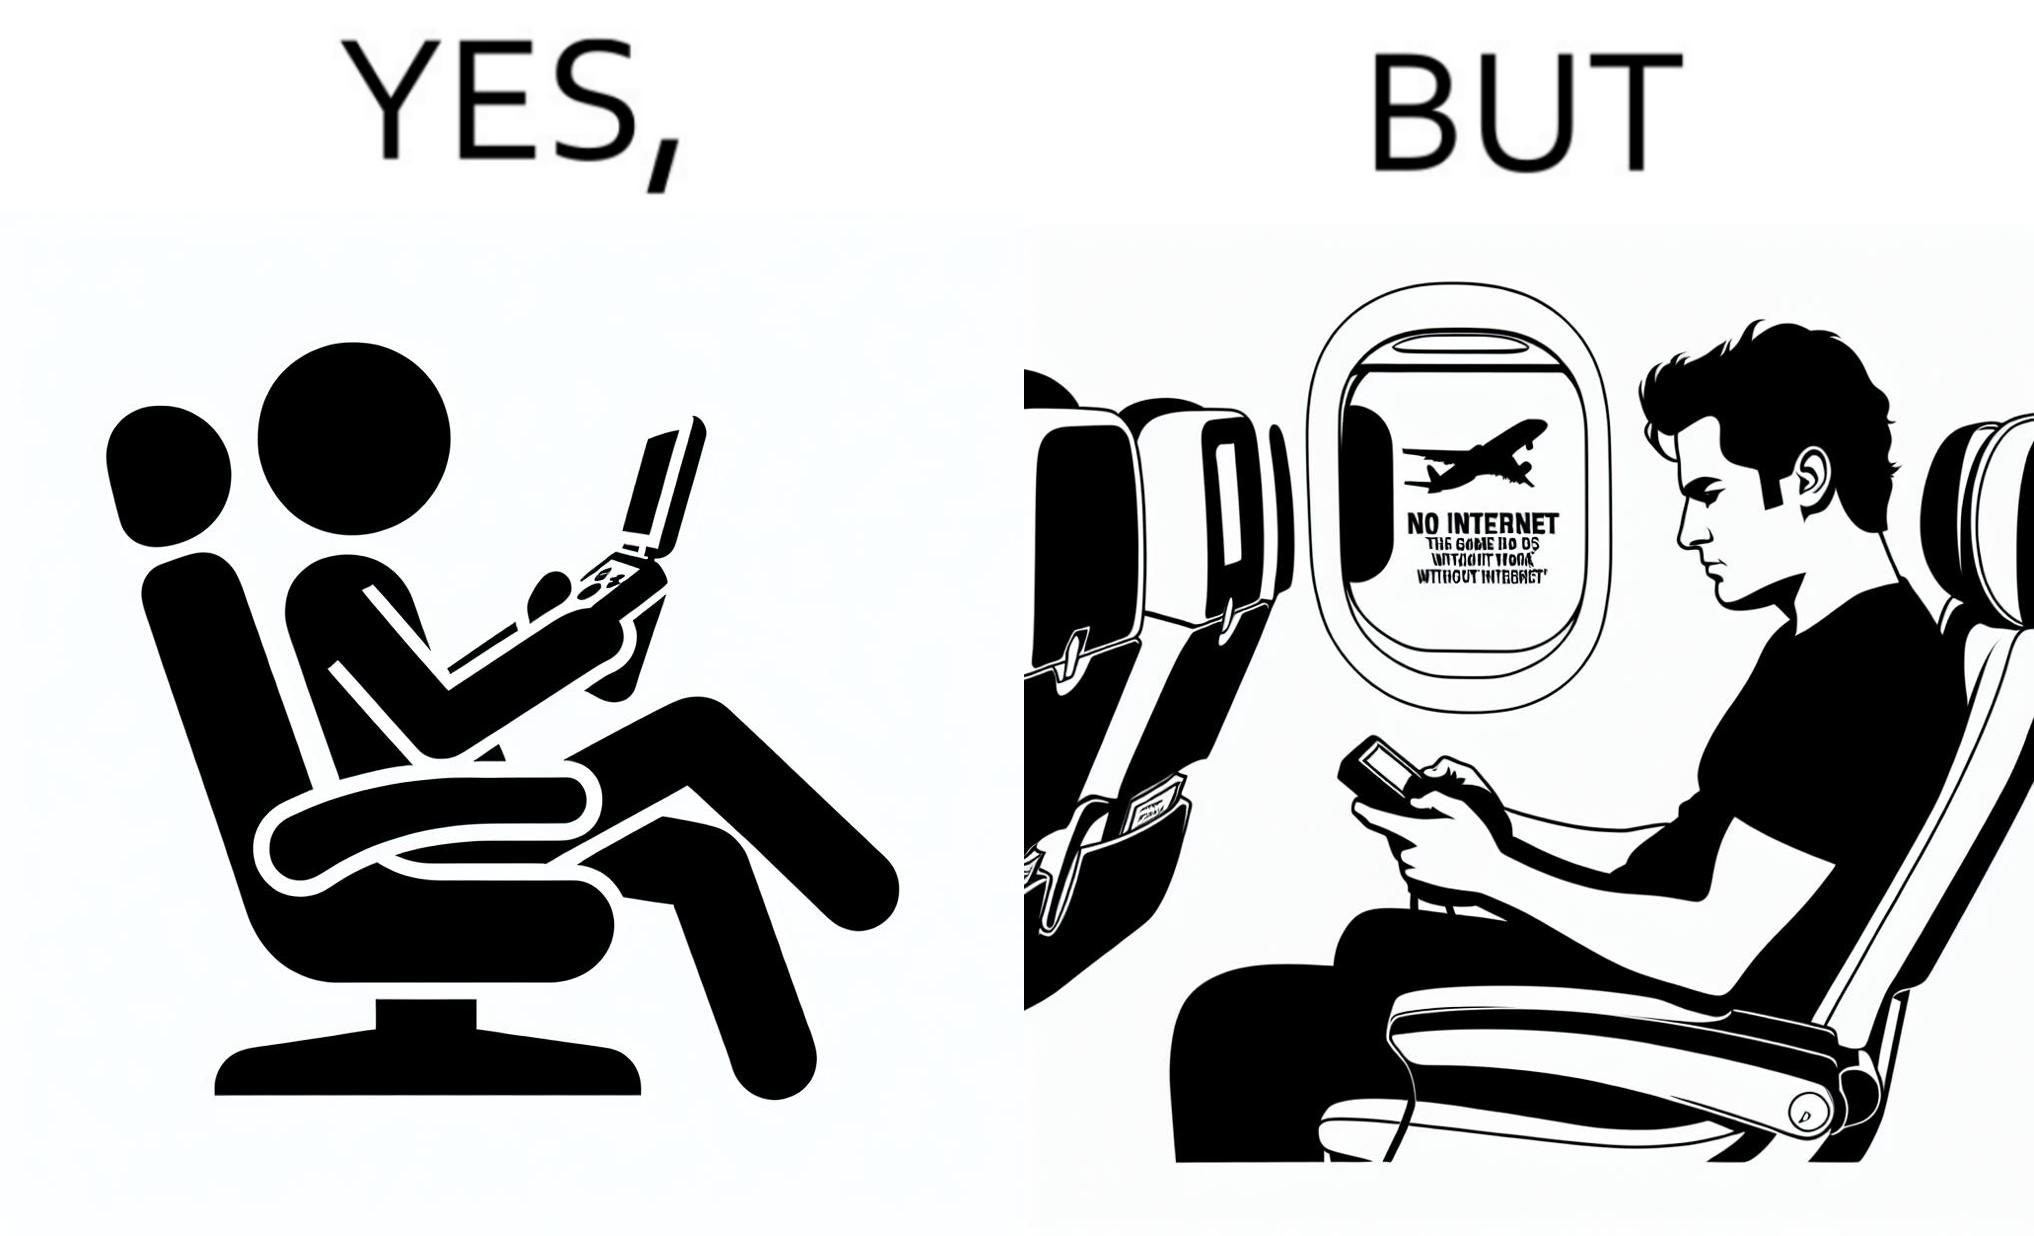Why is this image considered satirical? The image is ironic, as the person is holding the game console to play a game during the flight. However, the person is unable to play the game, as the game requires internet (as is the case with many modern games), and internet is unavailable in many lights. 